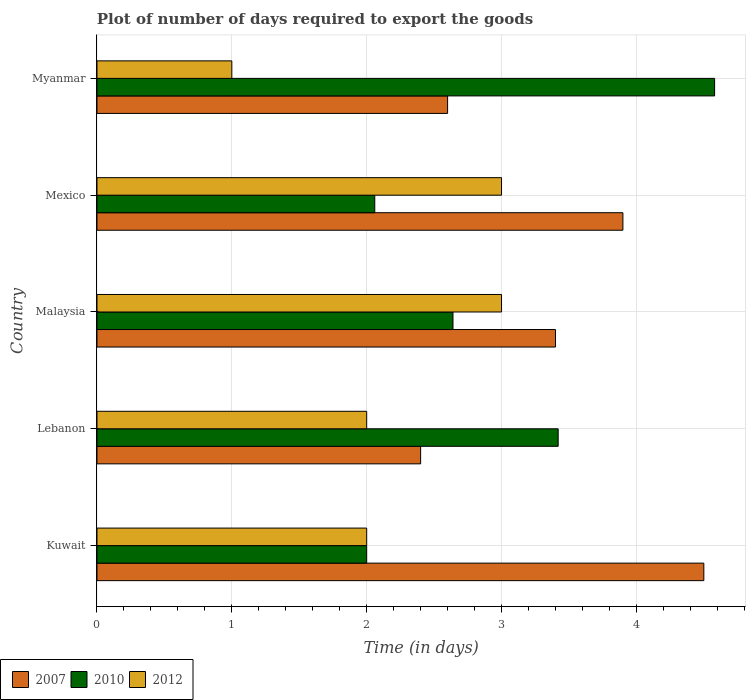Are the number of bars per tick equal to the number of legend labels?
Provide a short and direct response. Yes. How many bars are there on the 5th tick from the top?
Make the answer very short. 3. What is the label of the 5th group of bars from the top?
Your response must be concise. Kuwait. What is the time required to export goods in 2007 in Kuwait?
Provide a short and direct response. 4.5. Across all countries, what is the maximum time required to export goods in 2010?
Provide a short and direct response. 4.58. Across all countries, what is the minimum time required to export goods in 2010?
Your answer should be very brief. 2. In which country was the time required to export goods in 2007 maximum?
Your answer should be compact. Kuwait. In which country was the time required to export goods in 2012 minimum?
Your answer should be compact. Myanmar. What is the total time required to export goods in 2010 in the graph?
Keep it short and to the point. 14.7. What is the difference between the time required to export goods in 2007 in Myanmar and the time required to export goods in 2010 in Kuwait?
Ensure brevity in your answer.  0.6. What is the average time required to export goods in 2007 per country?
Your response must be concise. 3.36. What is the difference between the time required to export goods in 2012 and time required to export goods in 2010 in Myanmar?
Your response must be concise. -3.58. What is the ratio of the time required to export goods in 2012 in Mexico to that in Myanmar?
Your response must be concise. 3. Is the time required to export goods in 2007 in Lebanon less than that in Malaysia?
Your answer should be very brief. Yes. Is the difference between the time required to export goods in 2012 in Mexico and Myanmar greater than the difference between the time required to export goods in 2010 in Mexico and Myanmar?
Your answer should be very brief. Yes. What is the difference between the highest and the second highest time required to export goods in 2010?
Provide a short and direct response. 1.16. What is the difference between the highest and the lowest time required to export goods in 2010?
Ensure brevity in your answer.  2.58. In how many countries, is the time required to export goods in 2010 greater than the average time required to export goods in 2010 taken over all countries?
Offer a very short reply. 2. What does the 3rd bar from the top in Kuwait represents?
Your answer should be compact. 2007. What does the 1st bar from the bottom in Lebanon represents?
Your answer should be very brief. 2007. How many bars are there?
Your answer should be very brief. 15. Are all the bars in the graph horizontal?
Ensure brevity in your answer.  Yes. How many countries are there in the graph?
Provide a succinct answer. 5. Does the graph contain any zero values?
Provide a short and direct response. No. Does the graph contain grids?
Keep it short and to the point. Yes. How many legend labels are there?
Keep it short and to the point. 3. How are the legend labels stacked?
Offer a very short reply. Horizontal. What is the title of the graph?
Ensure brevity in your answer.  Plot of number of days required to export the goods. Does "2012" appear as one of the legend labels in the graph?
Make the answer very short. Yes. What is the label or title of the X-axis?
Your response must be concise. Time (in days). What is the Time (in days) of 2007 in Kuwait?
Provide a short and direct response. 4.5. What is the Time (in days) in 2012 in Kuwait?
Provide a short and direct response. 2. What is the Time (in days) of 2010 in Lebanon?
Ensure brevity in your answer.  3.42. What is the Time (in days) of 2010 in Malaysia?
Your answer should be compact. 2.64. What is the Time (in days) of 2012 in Malaysia?
Make the answer very short. 3. What is the Time (in days) in 2010 in Mexico?
Offer a terse response. 2.06. What is the Time (in days) in 2010 in Myanmar?
Provide a short and direct response. 4.58. Across all countries, what is the maximum Time (in days) in 2007?
Your response must be concise. 4.5. Across all countries, what is the maximum Time (in days) in 2010?
Keep it short and to the point. 4.58. Across all countries, what is the maximum Time (in days) of 2012?
Your answer should be compact. 3. Across all countries, what is the minimum Time (in days) of 2010?
Make the answer very short. 2. What is the total Time (in days) in 2007 in the graph?
Offer a terse response. 16.8. What is the total Time (in days) of 2012 in the graph?
Offer a terse response. 11. What is the difference between the Time (in days) in 2010 in Kuwait and that in Lebanon?
Give a very brief answer. -1.42. What is the difference between the Time (in days) in 2012 in Kuwait and that in Lebanon?
Your response must be concise. 0. What is the difference between the Time (in days) in 2010 in Kuwait and that in Malaysia?
Offer a very short reply. -0.64. What is the difference between the Time (in days) in 2007 in Kuwait and that in Mexico?
Offer a terse response. 0.6. What is the difference between the Time (in days) of 2010 in Kuwait and that in Mexico?
Provide a short and direct response. -0.06. What is the difference between the Time (in days) in 2012 in Kuwait and that in Mexico?
Your response must be concise. -1. What is the difference between the Time (in days) of 2007 in Kuwait and that in Myanmar?
Provide a short and direct response. 1.9. What is the difference between the Time (in days) in 2010 in Kuwait and that in Myanmar?
Keep it short and to the point. -2.58. What is the difference between the Time (in days) of 2010 in Lebanon and that in Malaysia?
Your answer should be compact. 0.78. What is the difference between the Time (in days) in 2007 in Lebanon and that in Mexico?
Offer a terse response. -1.5. What is the difference between the Time (in days) in 2010 in Lebanon and that in Mexico?
Offer a terse response. 1.36. What is the difference between the Time (in days) of 2012 in Lebanon and that in Mexico?
Offer a very short reply. -1. What is the difference between the Time (in days) of 2007 in Lebanon and that in Myanmar?
Offer a very short reply. -0.2. What is the difference between the Time (in days) in 2010 in Lebanon and that in Myanmar?
Offer a terse response. -1.16. What is the difference between the Time (in days) in 2010 in Malaysia and that in Mexico?
Make the answer very short. 0.58. What is the difference between the Time (in days) in 2007 in Malaysia and that in Myanmar?
Make the answer very short. 0.8. What is the difference between the Time (in days) of 2010 in Malaysia and that in Myanmar?
Your answer should be very brief. -1.94. What is the difference between the Time (in days) in 2007 in Mexico and that in Myanmar?
Your answer should be compact. 1.3. What is the difference between the Time (in days) of 2010 in Mexico and that in Myanmar?
Provide a succinct answer. -2.52. What is the difference between the Time (in days) in 2007 in Kuwait and the Time (in days) in 2012 in Lebanon?
Give a very brief answer. 2.5. What is the difference between the Time (in days) of 2010 in Kuwait and the Time (in days) of 2012 in Lebanon?
Offer a very short reply. 0. What is the difference between the Time (in days) in 2007 in Kuwait and the Time (in days) in 2010 in Malaysia?
Keep it short and to the point. 1.86. What is the difference between the Time (in days) of 2007 in Kuwait and the Time (in days) of 2012 in Malaysia?
Provide a short and direct response. 1.5. What is the difference between the Time (in days) of 2007 in Kuwait and the Time (in days) of 2010 in Mexico?
Provide a succinct answer. 2.44. What is the difference between the Time (in days) of 2010 in Kuwait and the Time (in days) of 2012 in Mexico?
Make the answer very short. -1. What is the difference between the Time (in days) of 2007 in Kuwait and the Time (in days) of 2010 in Myanmar?
Ensure brevity in your answer.  -0.08. What is the difference between the Time (in days) of 2007 in Lebanon and the Time (in days) of 2010 in Malaysia?
Provide a short and direct response. -0.24. What is the difference between the Time (in days) of 2010 in Lebanon and the Time (in days) of 2012 in Malaysia?
Offer a very short reply. 0.42. What is the difference between the Time (in days) of 2007 in Lebanon and the Time (in days) of 2010 in Mexico?
Your answer should be very brief. 0.34. What is the difference between the Time (in days) of 2010 in Lebanon and the Time (in days) of 2012 in Mexico?
Make the answer very short. 0.42. What is the difference between the Time (in days) of 2007 in Lebanon and the Time (in days) of 2010 in Myanmar?
Offer a terse response. -2.18. What is the difference between the Time (in days) of 2007 in Lebanon and the Time (in days) of 2012 in Myanmar?
Your answer should be compact. 1.4. What is the difference between the Time (in days) of 2010 in Lebanon and the Time (in days) of 2012 in Myanmar?
Provide a succinct answer. 2.42. What is the difference between the Time (in days) in 2007 in Malaysia and the Time (in days) in 2010 in Mexico?
Give a very brief answer. 1.34. What is the difference between the Time (in days) of 2010 in Malaysia and the Time (in days) of 2012 in Mexico?
Offer a very short reply. -0.36. What is the difference between the Time (in days) of 2007 in Malaysia and the Time (in days) of 2010 in Myanmar?
Your answer should be very brief. -1.18. What is the difference between the Time (in days) in 2010 in Malaysia and the Time (in days) in 2012 in Myanmar?
Offer a very short reply. 1.64. What is the difference between the Time (in days) of 2007 in Mexico and the Time (in days) of 2010 in Myanmar?
Keep it short and to the point. -0.68. What is the difference between the Time (in days) of 2010 in Mexico and the Time (in days) of 2012 in Myanmar?
Provide a short and direct response. 1.06. What is the average Time (in days) in 2007 per country?
Make the answer very short. 3.36. What is the average Time (in days) of 2010 per country?
Provide a succinct answer. 2.94. What is the difference between the Time (in days) of 2007 and Time (in days) of 2010 in Kuwait?
Provide a succinct answer. 2.5. What is the difference between the Time (in days) in 2007 and Time (in days) in 2012 in Kuwait?
Your answer should be compact. 2.5. What is the difference between the Time (in days) in 2010 and Time (in days) in 2012 in Kuwait?
Offer a very short reply. 0. What is the difference between the Time (in days) of 2007 and Time (in days) of 2010 in Lebanon?
Ensure brevity in your answer.  -1.02. What is the difference between the Time (in days) in 2007 and Time (in days) in 2012 in Lebanon?
Offer a very short reply. 0.4. What is the difference between the Time (in days) in 2010 and Time (in days) in 2012 in Lebanon?
Your answer should be very brief. 1.42. What is the difference between the Time (in days) of 2007 and Time (in days) of 2010 in Malaysia?
Offer a very short reply. 0.76. What is the difference between the Time (in days) of 2007 and Time (in days) of 2012 in Malaysia?
Your response must be concise. 0.4. What is the difference between the Time (in days) in 2010 and Time (in days) in 2012 in Malaysia?
Give a very brief answer. -0.36. What is the difference between the Time (in days) in 2007 and Time (in days) in 2010 in Mexico?
Provide a short and direct response. 1.84. What is the difference between the Time (in days) in 2010 and Time (in days) in 2012 in Mexico?
Your response must be concise. -0.94. What is the difference between the Time (in days) of 2007 and Time (in days) of 2010 in Myanmar?
Your answer should be very brief. -1.98. What is the difference between the Time (in days) in 2010 and Time (in days) in 2012 in Myanmar?
Provide a short and direct response. 3.58. What is the ratio of the Time (in days) in 2007 in Kuwait to that in Lebanon?
Provide a short and direct response. 1.88. What is the ratio of the Time (in days) of 2010 in Kuwait to that in Lebanon?
Your answer should be compact. 0.58. What is the ratio of the Time (in days) of 2012 in Kuwait to that in Lebanon?
Ensure brevity in your answer.  1. What is the ratio of the Time (in days) in 2007 in Kuwait to that in Malaysia?
Ensure brevity in your answer.  1.32. What is the ratio of the Time (in days) in 2010 in Kuwait to that in Malaysia?
Keep it short and to the point. 0.76. What is the ratio of the Time (in days) of 2012 in Kuwait to that in Malaysia?
Offer a very short reply. 0.67. What is the ratio of the Time (in days) of 2007 in Kuwait to that in Mexico?
Make the answer very short. 1.15. What is the ratio of the Time (in days) of 2010 in Kuwait to that in Mexico?
Give a very brief answer. 0.97. What is the ratio of the Time (in days) in 2007 in Kuwait to that in Myanmar?
Keep it short and to the point. 1.73. What is the ratio of the Time (in days) in 2010 in Kuwait to that in Myanmar?
Your answer should be very brief. 0.44. What is the ratio of the Time (in days) of 2007 in Lebanon to that in Malaysia?
Your answer should be very brief. 0.71. What is the ratio of the Time (in days) of 2010 in Lebanon to that in Malaysia?
Give a very brief answer. 1.3. What is the ratio of the Time (in days) of 2012 in Lebanon to that in Malaysia?
Keep it short and to the point. 0.67. What is the ratio of the Time (in days) in 2007 in Lebanon to that in Mexico?
Keep it short and to the point. 0.62. What is the ratio of the Time (in days) of 2010 in Lebanon to that in Mexico?
Offer a terse response. 1.66. What is the ratio of the Time (in days) of 2007 in Lebanon to that in Myanmar?
Offer a terse response. 0.92. What is the ratio of the Time (in days) of 2010 in Lebanon to that in Myanmar?
Make the answer very short. 0.75. What is the ratio of the Time (in days) of 2012 in Lebanon to that in Myanmar?
Your response must be concise. 2. What is the ratio of the Time (in days) of 2007 in Malaysia to that in Mexico?
Provide a succinct answer. 0.87. What is the ratio of the Time (in days) in 2010 in Malaysia to that in Mexico?
Keep it short and to the point. 1.28. What is the ratio of the Time (in days) in 2012 in Malaysia to that in Mexico?
Give a very brief answer. 1. What is the ratio of the Time (in days) of 2007 in Malaysia to that in Myanmar?
Your answer should be very brief. 1.31. What is the ratio of the Time (in days) of 2010 in Malaysia to that in Myanmar?
Your answer should be very brief. 0.58. What is the ratio of the Time (in days) in 2010 in Mexico to that in Myanmar?
Provide a short and direct response. 0.45. What is the difference between the highest and the second highest Time (in days) in 2007?
Give a very brief answer. 0.6. What is the difference between the highest and the second highest Time (in days) of 2010?
Offer a very short reply. 1.16. What is the difference between the highest and the second highest Time (in days) of 2012?
Your response must be concise. 0. What is the difference between the highest and the lowest Time (in days) in 2007?
Offer a very short reply. 2.1. What is the difference between the highest and the lowest Time (in days) of 2010?
Your answer should be compact. 2.58. What is the difference between the highest and the lowest Time (in days) in 2012?
Ensure brevity in your answer.  2. 